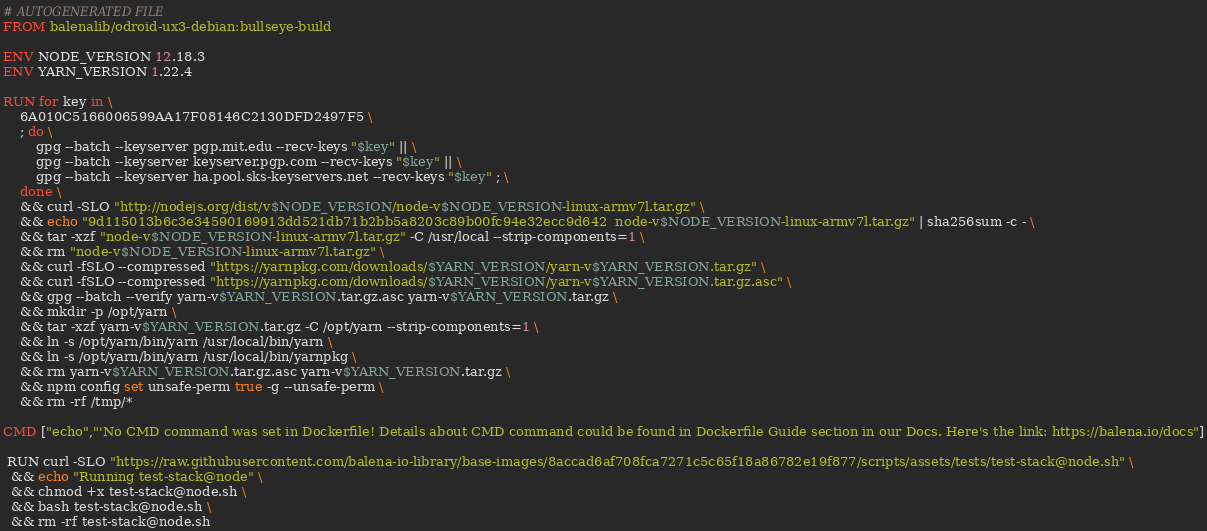Convert code to text. <code><loc_0><loc_0><loc_500><loc_500><_Dockerfile_># AUTOGENERATED FILE
FROM balenalib/odroid-ux3-debian:bullseye-build

ENV NODE_VERSION 12.18.3
ENV YARN_VERSION 1.22.4

RUN for key in \
	6A010C5166006599AA17F08146C2130DFD2497F5 \
	; do \
		gpg --batch --keyserver pgp.mit.edu --recv-keys "$key" || \
		gpg --batch --keyserver keyserver.pgp.com --recv-keys "$key" || \
		gpg --batch --keyserver ha.pool.sks-keyservers.net --recv-keys "$key" ; \
	done \
	&& curl -SLO "http://nodejs.org/dist/v$NODE_VERSION/node-v$NODE_VERSION-linux-armv7l.tar.gz" \
	&& echo "9d115013b6c3e34590169913dd521db71b2bb5a8203c89b00fc94e32ecc9d642  node-v$NODE_VERSION-linux-armv7l.tar.gz" | sha256sum -c - \
	&& tar -xzf "node-v$NODE_VERSION-linux-armv7l.tar.gz" -C /usr/local --strip-components=1 \
	&& rm "node-v$NODE_VERSION-linux-armv7l.tar.gz" \
	&& curl -fSLO --compressed "https://yarnpkg.com/downloads/$YARN_VERSION/yarn-v$YARN_VERSION.tar.gz" \
	&& curl -fSLO --compressed "https://yarnpkg.com/downloads/$YARN_VERSION/yarn-v$YARN_VERSION.tar.gz.asc" \
	&& gpg --batch --verify yarn-v$YARN_VERSION.tar.gz.asc yarn-v$YARN_VERSION.tar.gz \
	&& mkdir -p /opt/yarn \
	&& tar -xzf yarn-v$YARN_VERSION.tar.gz -C /opt/yarn --strip-components=1 \
	&& ln -s /opt/yarn/bin/yarn /usr/local/bin/yarn \
	&& ln -s /opt/yarn/bin/yarn /usr/local/bin/yarnpkg \
	&& rm yarn-v$YARN_VERSION.tar.gz.asc yarn-v$YARN_VERSION.tar.gz \
	&& npm config set unsafe-perm true -g --unsafe-perm \
	&& rm -rf /tmp/*

CMD ["echo","'No CMD command was set in Dockerfile! Details about CMD command could be found in Dockerfile Guide section in our Docs. Here's the link: https://balena.io/docs"]

 RUN curl -SLO "https://raw.githubusercontent.com/balena-io-library/base-images/8accad6af708fca7271c5c65f18a86782e19f877/scripts/assets/tests/test-stack@node.sh" \
  && echo "Running test-stack@node" \
  && chmod +x test-stack@node.sh \
  && bash test-stack@node.sh \
  && rm -rf test-stack@node.sh 
</code> 